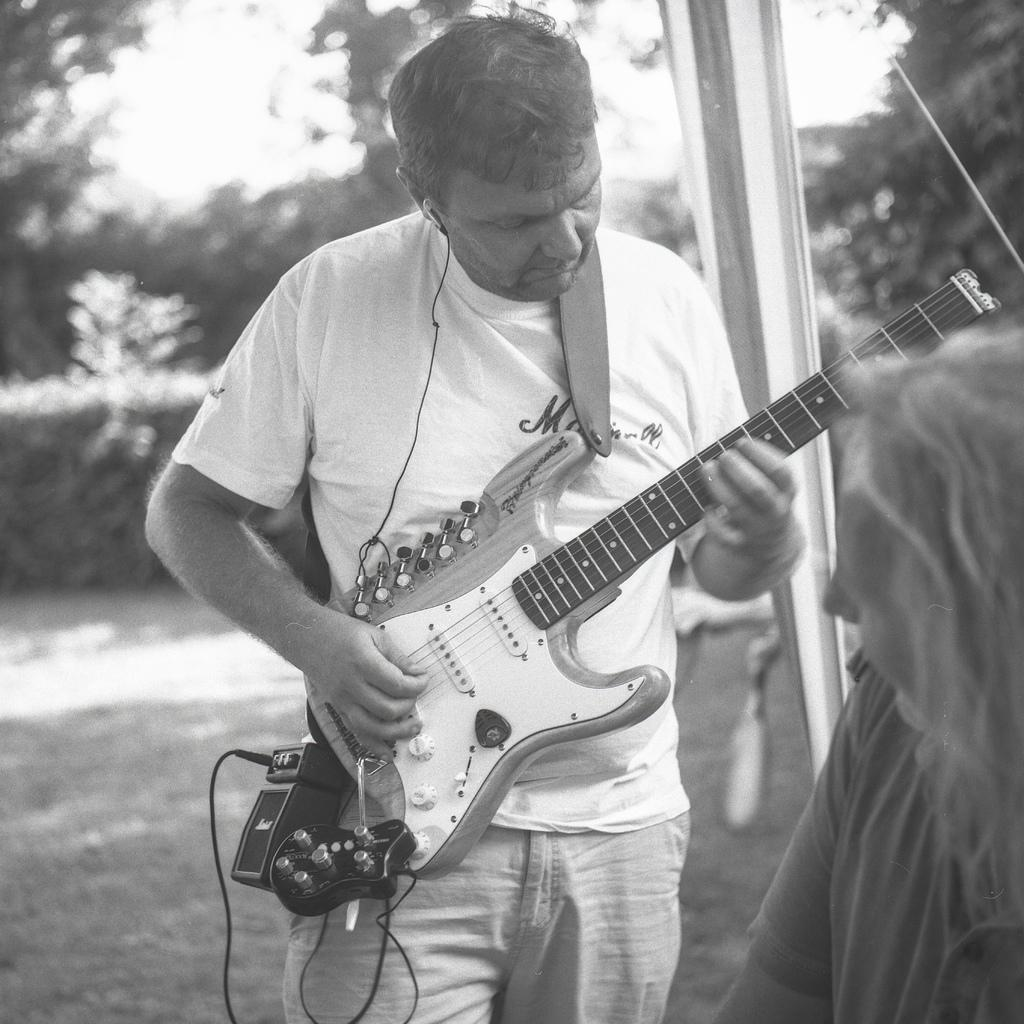What is the man in the image doing? The man is playing a guitar in the image. Who is the man playing the guitar for? The woman in the image is watching the man play the guitar. What is the woman's role in the image? The woman is observing the man play the guitar. What type of cap is the brother wearing on the ship in the image? There is no brother or ship present in the image, and therefore no cap can be observed. 